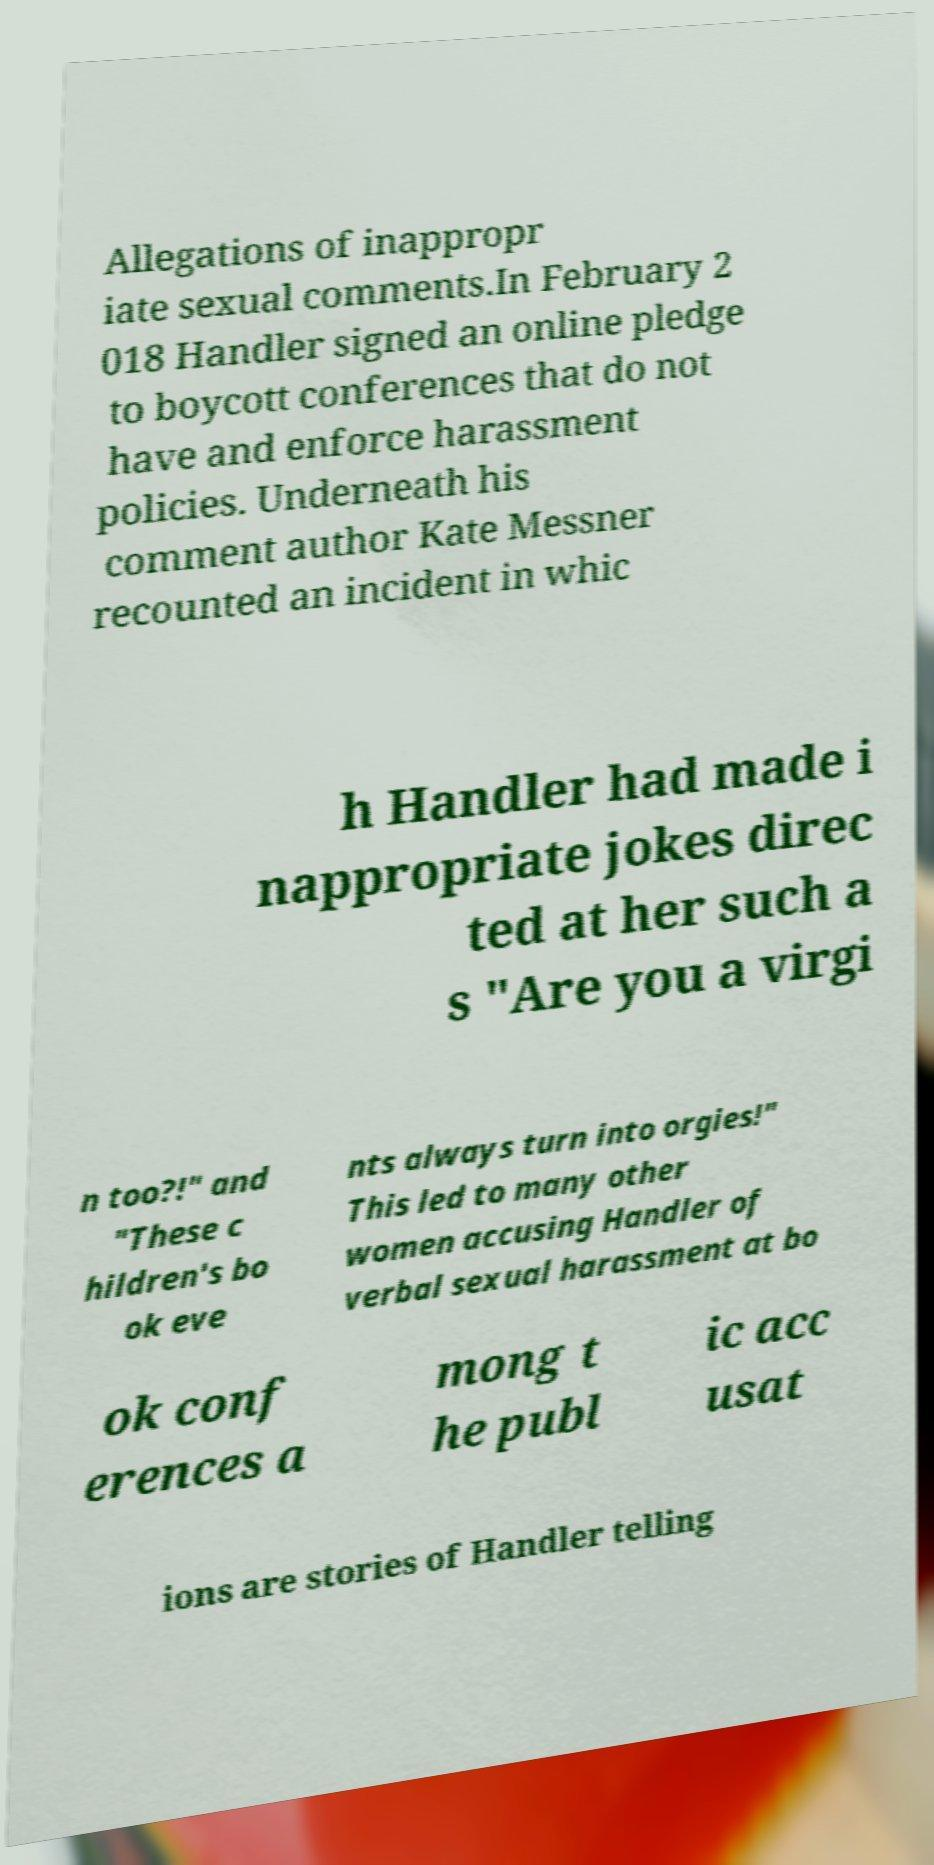What messages or text are displayed in this image? I need them in a readable, typed format. Allegations of inappropr iate sexual comments.In February 2 018 Handler signed an online pledge to boycott conferences that do not have and enforce harassment policies. Underneath his comment author Kate Messner recounted an incident in whic h Handler had made i nappropriate jokes direc ted at her such a s "Are you a virgi n too?!" and "These c hildren's bo ok eve nts always turn into orgies!" This led to many other women accusing Handler of verbal sexual harassment at bo ok conf erences a mong t he publ ic acc usat ions are stories of Handler telling 